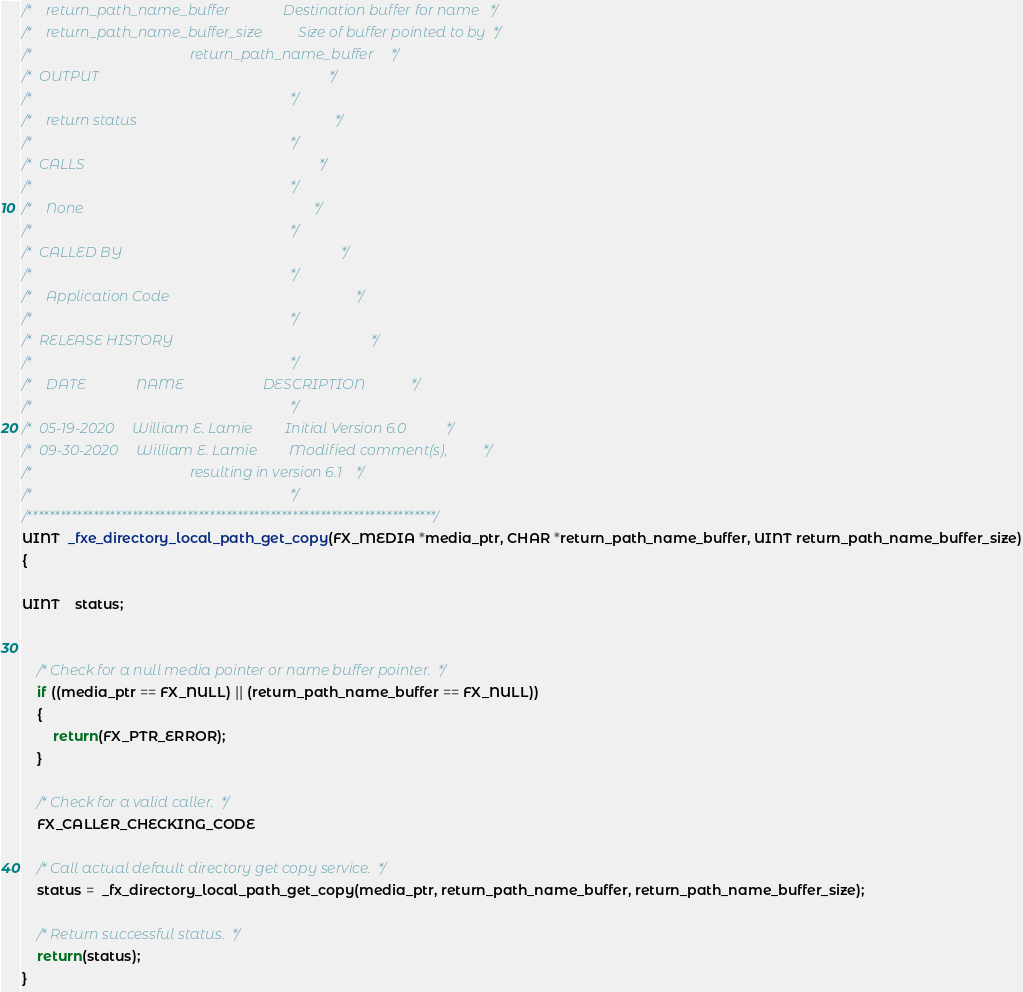<code> <loc_0><loc_0><loc_500><loc_500><_C_>/*    return_path_name_buffer               Destination buffer for name   */
/*    return_path_name_buffer_size          Size of buffer pointed to by  */
/*                                            return_path_name_buffer     */
/*  OUTPUT                                                                */
/*                                                                        */
/*    return status                                                       */
/*                                                                        */
/*  CALLS                                                                 */
/*                                                                        */
/*    None                                                                */
/*                                                                        */
/*  CALLED BY                                                             */
/*                                                                        */
/*    Application Code                                                    */
/*                                                                        */
/*  RELEASE HISTORY                                                       */
/*                                                                        */
/*    DATE              NAME                      DESCRIPTION             */
/*                                                                        */
/*  05-19-2020     William E. Lamie         Initial Version 6.0           */
/*  09-30-2020     William E. Lamie         Modified comment(s),          */
/*                                            resulting in version 6.1    */
/*                                                                        */
/**************************************************************************/
UINT  _fxe_directory_local_path_get_copy(FX_MEDIA *media_ptr, CHAR *return_path_name_buffer, UINT return_path_name_buffer_size)
{

UINT    status;


    /* Check for a null media pointer or name buffer pointer.  */
    if ((media_ptr == FX_NULL) || (return_path_name_buffer == FX_NULL))
    {
        return(FX_PTR_ERROR);
    }

    /* Check for a valid caller.  */
    FX_CALLER_CHECKING_CODE

    /* Call actual default directory get copy service.  */
    status =  _fx_directory_local_path_get_copy(media_ptr, return_path_name_buffer, return_path_name_buffer_size);

    /* Return successful status.  */
    return(status);
}
</code> 